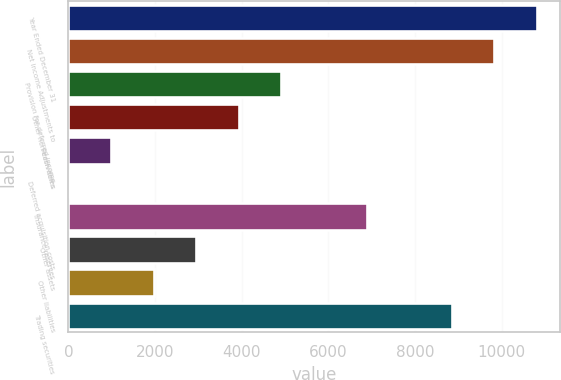<chart> <loc_0><loc_0><loc_500><loc_500><bar_chart><fcel>Year Ended December 31<fcel>Net income Adjustments to<fcel>Provision for deferred income<fcel>Other non-cash items<fcel>Receivables<fcel>Deferred acquisition costs<fcel>Insurance reserves<fcel>Other assets<fcel>Other liabilities<fcel>Trading securities<nl><fcel>10808.9<fcel>9827<fcel>4917.5<fcel>3935.6<fcel>989.9<fcel>8<fcel>6881.3<fcel>2953.7<fcel>1971.8<fcel>8845.1<nl></chart> 